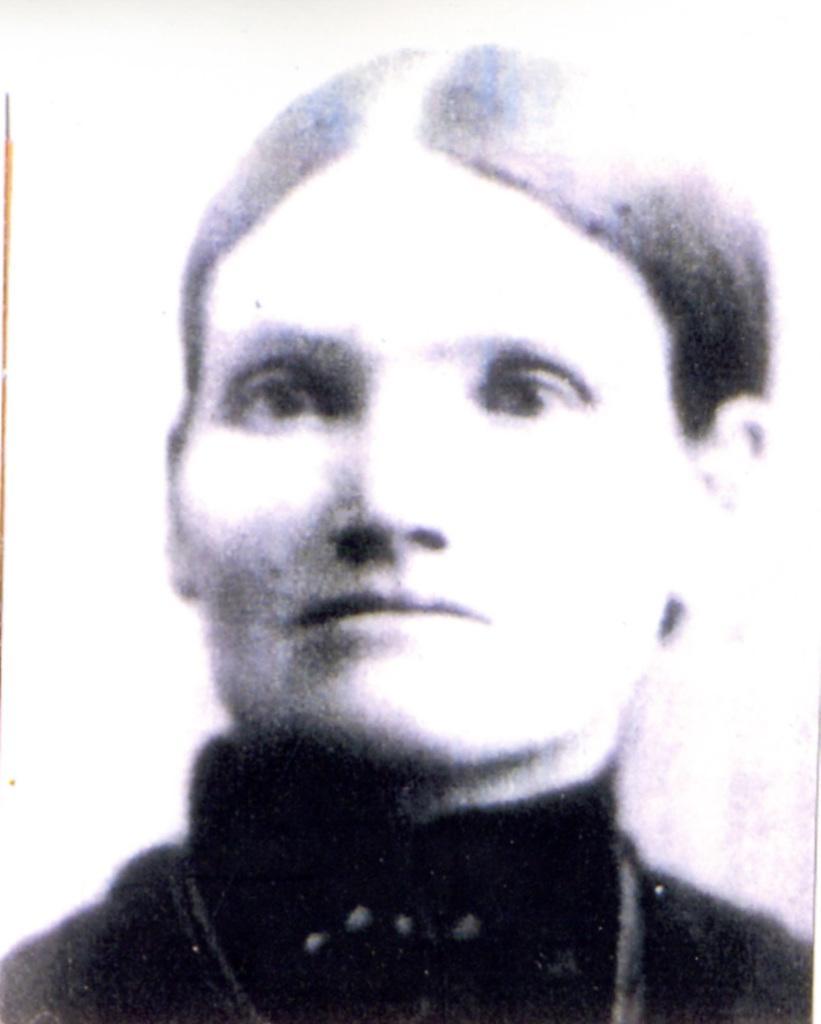Please provide a concise description of this image. As we can see in the image there is a man wearing black color dress. 